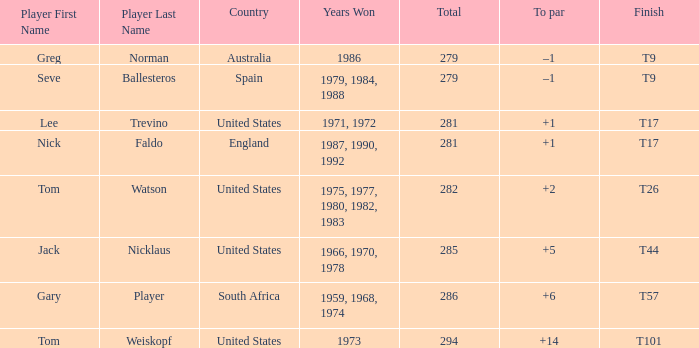Which player is from Australia? Greg Norman. 